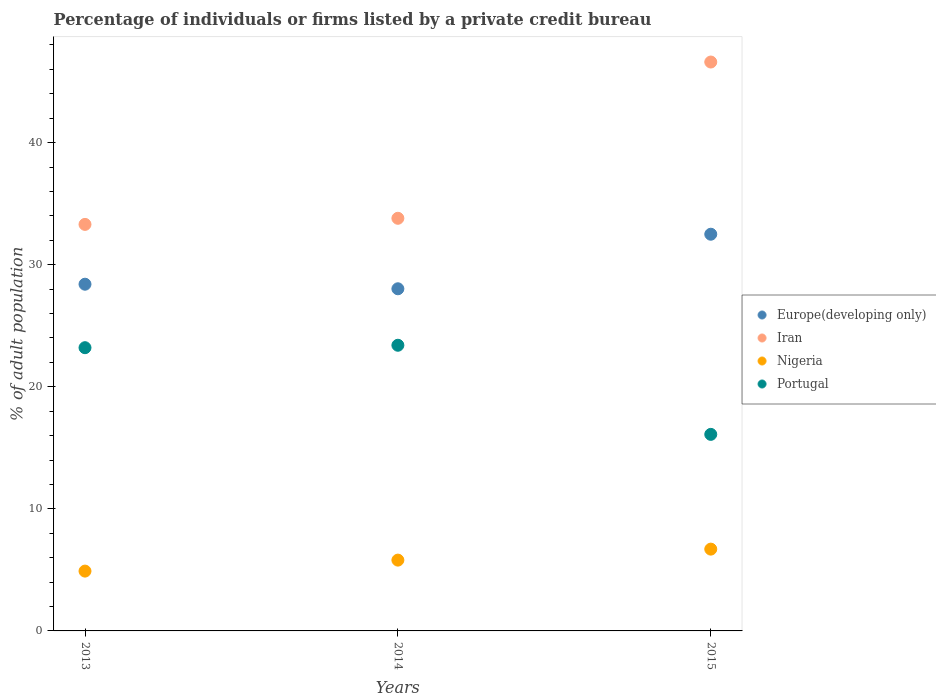How many different coloured dotlines are there?
Provide a short and direct response. 4. What is the percentage of population listed by a private credit bureau in Iran in 2015?
Your answer should be compact. 46.6. Across all years, what is the maximum percentage of population listed by a private credit bureau in Iran?
Your response must be concise. 46.6. Across all years, what is the minimum percentage of population listed by a private credit bureau in Europe(developing only)?
Make the answer very short. 28.03. In which year was the percentage of population listed by a private credit bureau in Nigeria maximum?
Make the answer very short. 2015. In which year was the percentage of population listed by a private credit bureau in Portugal minimum?
Make the answer very short. 2015. What is the total percentage of population listed by a private credit bureau in Europe(developing only) in the graph?
Keep it short and to the point. 88.92. What is the difference between the percentage of population listed by a private credit bureau in Iran in 2014 and that in 2015?
Your answer should be very brief. -12.8. What is the difference between the percentage of population listed by a private credit bureau in Europe(developing only) in 2015 and the percentage of population listed by a private credit bureau in Portugal in 2013?
Provide a short and direct response. 9.29. What is the average percentage of population listed by a private credit bureau in Portugal per year?
Ensure brevity in your answer.  20.9. In the year 2013, what is the difference between the percentage of population listed by a private credit bureau in Iran and percentage of population listed by a private credit bureau in Portugal?
Your response must be concise. 10.1. What is the ratio of the percentage of population listed by a private credit bureau in Nigeria in 2013 to that in 2014?
Provide a short and direct response. 0.84. What is the difference between the highest and the second highest percentage of population listed by a private credit bureau in Iran?
Your answer should be very brief. 12.8. What is the difference between the highest and the lowest percentage of population listed by a private credit bureau in Iran?
Ensure brevity in your answer.  13.3. In how many years, is the percentage of population listed by a private credit bureau in Europe(developing only) greater than the average percentage of population listed by a private credit bureau in Europe(developing only) taken over all years?
Your answer should be very brief. 1. Is the percentage of population listed by a private credit bureau in Nigeria strictly less than the percentage of population listed by a private credit bureau in Europe(developing only) over the years?
Your response must be concise. Yes. How many dotlines are there?
Ensure brevity in your answer.  4. Are the values on the major ticks of Y-axis written in scientific E-notation?
Provide a succinct answer. No. Does the graph contain any zero values?
Provide a succinct answer. No. Does the graph contain grids?
Your response must be concise. No. How are the legend labels stacked?
Provide a succinct answer. Vertical. What is the title of the graph?
Your answer should be very brief. Percentage of individuals or firms listed by a private credit bureau. What is the label or title of the Y-axis?
Provide a short and direct response. % of adult population. What is the % of adult population of Europe(developing only) in 2013?
Provide a succinct answer. 28.4. What is the % of adult population of Iran in 2013?
Offer a terse response. 33.3. What is the % of adult population in Nigeria in 2013?
Offer a terse response. 4.9. What is the % of adult population in Portugal in 2013?
Provide a succinct answer. 23.2. What is the % of adult population in Europe(developing only) in 2014?
Make the answer very short. 28.03. What is the % of adult population of Iran in 2014?
Offer a terse response. 33.8. What is the % of adult population in Nigeria in 2014?
Provide a short and direct response. 5.8. What is the % of adult population of Portugal in 2014?
Provide a short and direct response. 23.4. What is the % of adult population in Europe(developing only) in 2015?
Make the answer very short. 32.49. What is the % of adult population in Iran in 2015?
Provide a short and direct response. 46.6. Across all years, what is the maximum % of adult population of Europe(developing only)?
Your answer should be compact. 32.49. Across all years, what is the maximum % of adult population in Iran?
Your answer should be compact. 46.6. Across all years, what is the maximum % of adult population in Nigeria?
Make the answer very short. 6.7. Across all years, what is the maximum % of adult population of Portugal?
Make the answer very short. 23.4. Across all years, what is the minimum % of adult population of Europe(developing only)?
Make the answer very short. 28.03. Across all years, what is the minimum % of adult population of Iran?
Give a very brief answer. 33.3. Across all years, what is the minimum % of adult population in Nigeria?
Keep it short and to the point. 4.9. Across all years, what is the minimum % of adult population of Portugal?
Provide a succinct answer. 16.1. What is the total % of adult population in Europe(developing only) in the graph?
Keep it short and to the point. 88.92. What is the total % of adult population in Iran in the graph?
Your response must be concise. 113.7. What is the total % of adult population of Portugal in the graph?
Offer a terse response. 62.7. What is the difference between the % of adult population of Europe(developing only) in 2013 and that in 2014?
Keep it short and to the point. 0.37. What is the difference between the % of adult population of Nigeria in 2013 and that in 2014?
Offer a terse response. -0.9. What is the difference between the % of adult population of Portugal in 2013 and that in 2014?
Provide a succinct answer. -0.2. What is the difference between the % of adult population of Europe(developing only) in 2013 and that in 2015?
Provide a succinct answer. -4.09. What is the difference between the % of adult population of Portugal in 2013 and that in 2015?
Ensure brevity in your answer.  7.1. What is the difference between the % of adult population in Europe(developing only) in 2014 and that in 2015?
Ensure brevity in your answer.  -4.47. What is the difference between the % of adult population in Europe(developing only) in 2013 and the % of adult population in Iran in 2014?
Ensure brevity in your answer.  -5.4. What is the difference between the % of adult population of Europe(developing only) in 2013 and the % of adult population of Nigeria in 2014?
Your answer should be very brief. 22.6. What is the difference between the % of adult population of Iran in 2013 and the % of adult population of Nigeria in 2014?
Make the answer very short. 27.5. What is the difference between the % of adult population in Iran in 2013 and the % of adult population in Portugal in 2014?
Your response must be concise. 9.9. What is the difference between the % of adult population of Nigeria in 2013 and the % of adult population of Portugal in 2014?
Your answer should be very brief. -18.5. What is the difference between the % of adult population in Europe(developing only) in 2013 and the % of adult population in Iran in 2015?
Offer a very short reply. -18.2. What is the difference between the % of adult population in Europe(developing only) in 2013 and the % of adult population in Nigeria in 2015?
Provide a short and direct response. 21.7. What is the difference between the % of adult population in Iran in 2013 and the % of adult population in Nigeria in 2015?
Keep it short and to the point. 26.6. What is the difference between the % of adult population in Europe(developing only) in 2014 and the % of adult population in Iran in 2015?
Your response must be concise. -18.57. What is the difference between the % of adult population of Europe(developing only) in 2014 and the % of adult population of Nigeria in 2015?
Offer a terse response. 21.33. What is the difference between the % of adult population of Europe(developing only) in 2014 and the % of adult population of Portugal in 2015?
Your answer should be very brief. 11.93. What is the difference between the % of adult population in Iran in 2014 and the % of adult population in Nigeria in 2015?
Your answer should be compact. 27.1. What is the difference between the % of adult population of Nigeria in 2014 and the % of adult population of Portugal in 2015?
Provide a short and direct response. -10.3. What is the average % of adult population in Europe(developing only) per year?
Ensure brevity in your answer.  29.64. What is the average % of adult population in Iran per year?
Ensure brevity in your answer.  37.9. What is the average % of adult population in Portugal per year?
Ensure brevity in your answer.  20.9. In the year 2013, what is the difference between the % of adult population of Europe(developing only) and % of adult population of Nigeria?
Your answer should be very brief. 23.5. In the year 2013, what is the difference between the % of adult population in Europe(developing only) and % of adult population in Portugal?
Provide a short and direct response. 5.2. In the year 2013, what is the difference between the % of adult population in Iran and % of adult population in Nigeria?
Provide a succinct answer. 28.4. In the year 2013, what is the difference between the % of adult population in Nigeria and % of adult population in Portugal?
Give a very brief answer. -18.3. In the year 2014, what is the difference between the % of adult population in Europe(developing only) and % of adult population in Iran?
Provide a succinct answer. -5.77. In the year 2014, what is the difference between the % of adult population of Europe(developing only) and % of adult population of Nigeria?
Offer a very short reply. 22.23. In the year 2014, what is the difference between the % of adult population in Europe(developing only) and % of adult population in Portugal?
Keep it short and to the point. 4.63. In the year 2014, what is the difference between the % of adult population of Nigeria and % of adult population of Portugal?
Your answer should be very brief. -17.6. In the year 2015, what is the difference between the % of adult population in Europe(developing only) and % of adult population in Iran?
Make the answer very short. -14.11. In the year 2015, what is the difference between the % of adult population of Europe(developing only) and % of adult population of Nigeria?
Your answer should be compact. 25.79. In the year 2015, what is the difference between the % of adult population of Europe(developing only) and % of adult population of Portugal?
Your answer should be compact. 16.39. In the year 2015, what is the difference between the % of adult population of Iran and % of adult population of Nigeria?
Provide a short and direct response. 39.9. In the year 2015, what is the difference between the % of adult population in Iran and % of adult population in Portugal?
Provide a succinct answer. 30.5. What is the ratio of the % of adult population in Europe(developing only) in 2013 to that in 2014?
Make the answer very short. 1.01. What is the ratio of the % of adult population of Iran in 2013 to that in 2014?
Offer a terse response. 0.99. What is the ratio of the % of adult population of Nigeria in 2013 to that in 2014?
Make the answer very short. 0.84. What is the ratio of the % of adult population in Portugal in 2013 to that in 2014?
Your answer should be compact. 0.99. What is the ratio of the % of adult population in Europe(developing only) in 2013 to that in 2015?
Ensure brevity in your answer.  0.87. What is the ratio of the % of adult population of Iran in 2013 to that in 2015?
Ensure brevity in your answer.  0.71. What is the ratio of the % of adult population in Nigeria in 2013 to that in 2015?
Give a very brief answer. 0.73. What is the ratio of the % of adult population in Portugal in 2013 to that in 2015?
Your answer should be compact. 1.44. What is the ratio of the % of adult population of Europe(developing only) in 2014 to that in 2015?
Give a very brief answer. 0.86. What is the ratio of the % of adult population in Iran in 2014 to that in 2015?
Your answer should be compact. 0.73. What is the ratio of the % of adult population of Nigeria in 2014 to that in 2015?
Keep it short and to the point. 0.87. What is the ratio of the % of adult population in Portugal in 2014 to that in 2015?
Your answer should be very brief. 1.45. What is the difference between the highest and the second highest % of adult population in Europe(developing only)?
Your answer should be compact. 4.09. What is the difference between the highest and the second highest % of adult population in Iran?
Provide a short and direct response. 12.8. What is the difference between the highest and the second highest % of adult population of Portugal?
Your answer should be compact. 0.2. What is the difference between the highest and the lowest % of adult population in Europe(developing only)?
Make the answer very short. 4.47. What is the difference between the highest and the lowest % of adult population in Iran?
Your response must be concise. 13.3. 